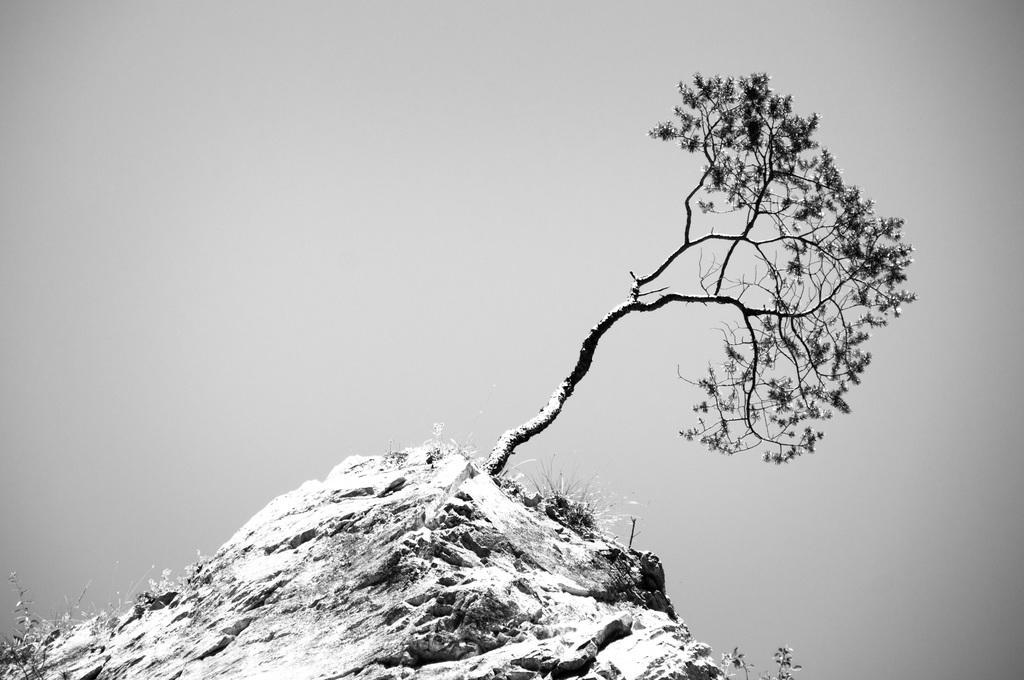Please provide a concise description of this image. In this picture there is a tree on the mountain. At the bottom left corner we can see grass. In the back we can see sky and clouds. 